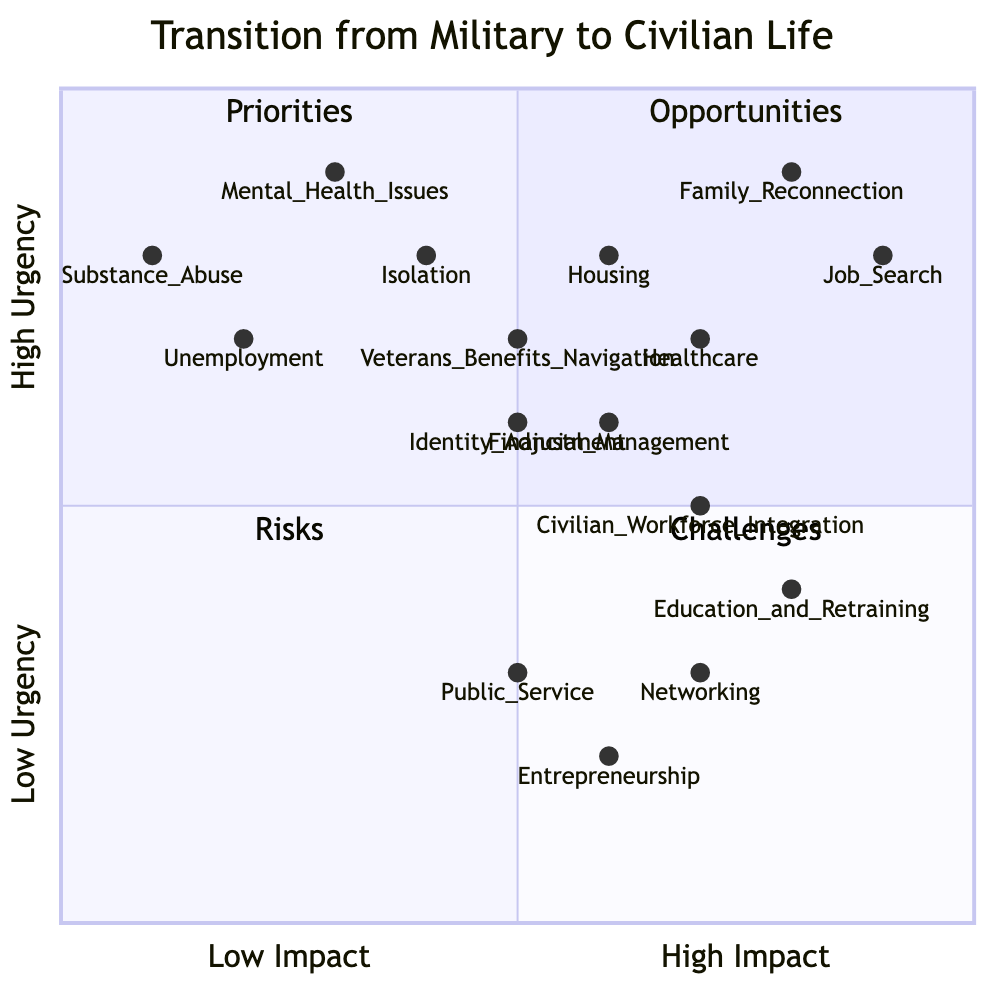What is the position of Job Search in the quadrants? The 'Job Search' priority is located in Quadrant 2, which represents Priorities. Its coordinates indicate it has high urgency (0.8) and very high impact (0.9).
Answer: Quadrant 2 Which node represents the highest urgency in Risks? The 'Mental Health Issues' is situated at a coordinate of (0.3, 0.9) in Quadrant 3, indicating it has the highest urgency among the risks listed.
Answer: Mental Health Issues How many nodes are there in total across all quadrants? By counting each of the nodes from Priorities, Challenges, Opportunities, and Risks sections, we see there are 16 nodes in total.
Answer: 16 What challenges have a higher impact than 'Isolation'? By examining 'Isolation' at (0.4, 0.8), the challenges above it with higher impact are 'Financial Management' and 'Veterans Benefits Navigation', which have impacts greater than 0.4.
Answer: Financial Management, Veterans Benefits Navigation Which opportunity has the lowest urgency? The 'Entrepreneurship' opportunity is positioned at (0.6, 0.2) in Quadrant 1, with the lowest urgency score compared to other opportunities listed.
Answer: Entrepreneurship Which priority has the least impact? The 'Housing' priority is indicated at (0.6, 0.8), having the least impact among the identified priorities.
Answer: Housing What is the average urgency of the Risks? Adding up the urgency scores of the risks (0.8 + 0.9 + 0.7 + 0.8 = 3.2) and dividing by the number of risks (4) gives us an average urgency of 0.8.
Answer: 0.8 How do the opportunities compare in terms of urgency? The 'Networking' opportunity at (0.7, 0.3) has the highest urgency among opportunities, with the rest (Education and Retraining, Entrepreneurship, and Public Service) comparing lower in urgency measures.
Answer: Networking Which quadrant contains nodes that primarily involve transition challenges? Quadrant 4 is designated for Challenges, containing all nodes associated with transition difficulties like 'Identity Adjustment' and 'Civilian Workforce Integration.'
Answer: Quadrant 4 